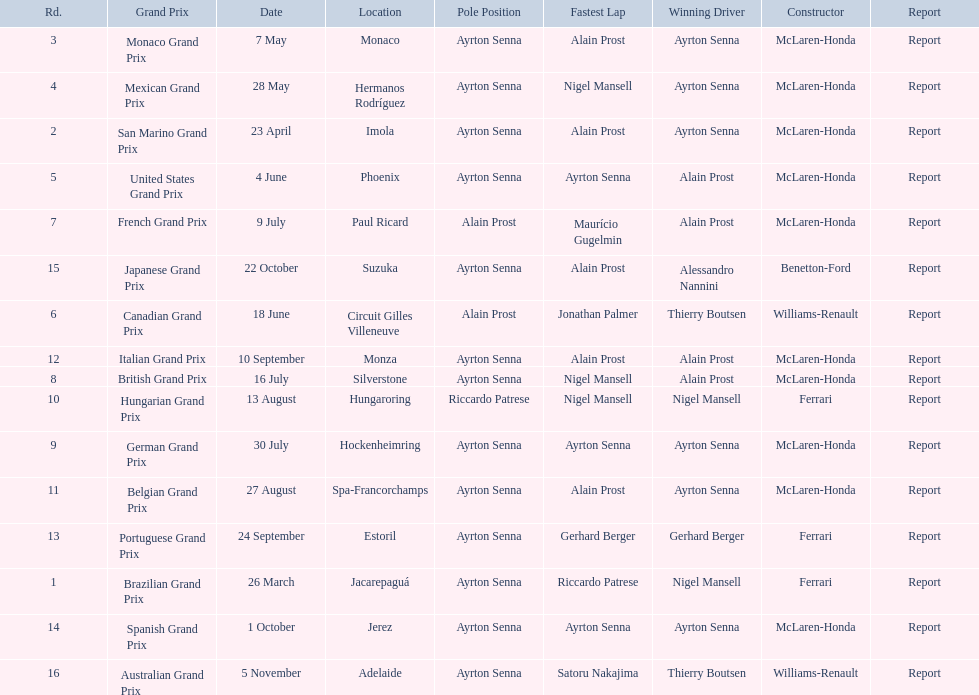Who are the constructors in the 1989 formula one season? Ferrari, McLaren-Honda, McLaren-Honda, McLaren-Honda, McLaren-Honda, Williams-Renault, McLaren-Honda, McLaren-Honda, McLaren-Honda, Ferrari, McLaren-Honda, McLaren-Honda, Ferrari, McLaren-Honda, Benetton-Ford, Williams-Renault. On what date was bennington ford the constructor? 22 October. What was the race on october 22? Japanese Grand Prix. 